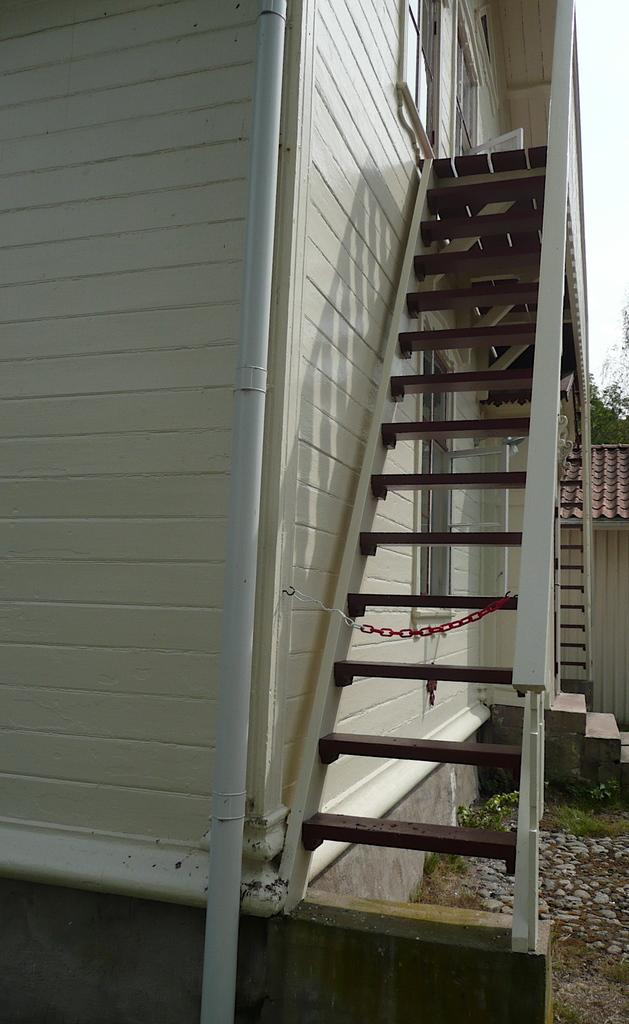What type of structure is visible in the image? There is a building in the image. What object can be seen near the building? There is a pipe in the image. Are there any architectural features present in the image? Yes, there are steps in the image. What additional object can be seen in the image? There is a chain in the image. How many eggs are visible on the chin of the person in the image? There is no person present in the image, and therefore no chin or eggs can be observed. 